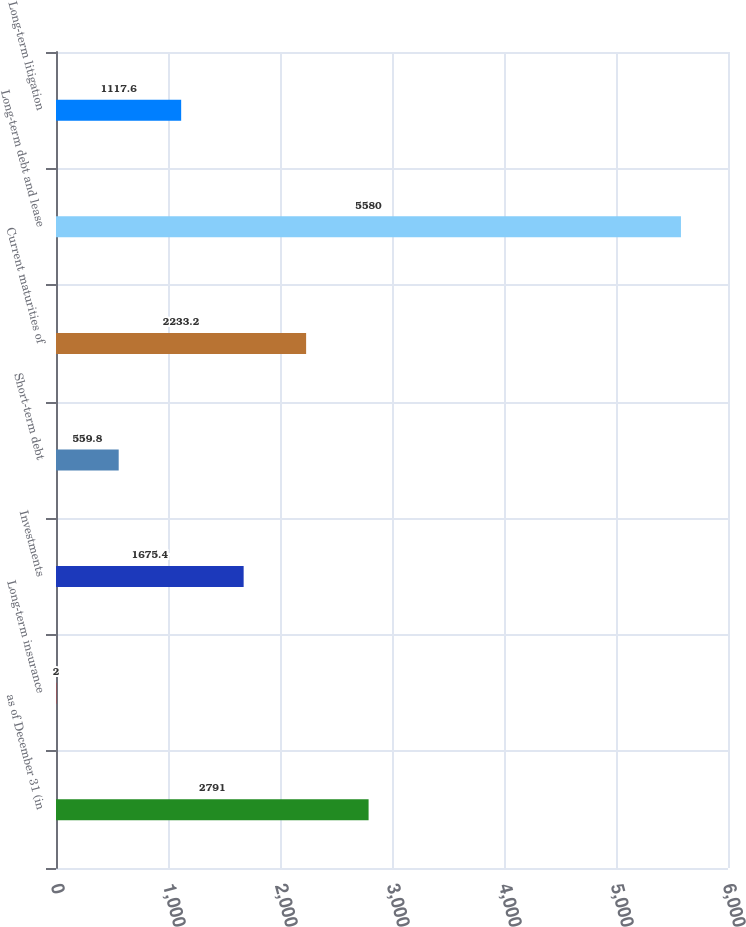Convert chart. <chart><loc_0><loc_0><loc_500><loc_500><bar_chart><fcel>as of December 31 (in<fcel>Long-term insurance<fcel>Investments<fcel>Short-term debt<fcel>Current maturities of<fcel>Long-term debt and lease<fcel>Long-term litigation<nl><fcel>2791<fcel>2<fcel>1675.4<fcel>559.8<fcel>2233.2<fcel>5580<fcel>1117.6<nl></chart> 